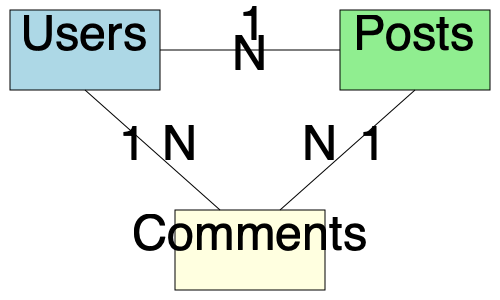In the given entity-relationship diagram, what type of relationship exists between the "Users" and "Posts" entities? To determine the relationship between "Users" and "Posts" entities, we need to analyze the diagram step-by-step:

1. Identify the entities: We can see three entities in the diagram - Users, Posts, and Comments.

2. Look for the connection: There is a direct line connecting the Users and Posts entities.

3. Examine the cardinality: Near the line connecting Users and Posts, we can see two numbers:
   - "1" on the Users side
   - "N" on the Posts side

4. Interpret the cardinality:
   - "1" near Users means that one user can be associated with multiple posts
   - "N" near Posts means that multiple posts can be associated with a single user

5. Determine the relationship type: When we have a "1" on one side and an "N" on the other side, this indicates a one-to-many relationship.

Therefore, the relationship between Users and Posts is a one-to-many relationship, where one user can have multiple posts, but each post is associated with only one user.
Answer: One-to-many 